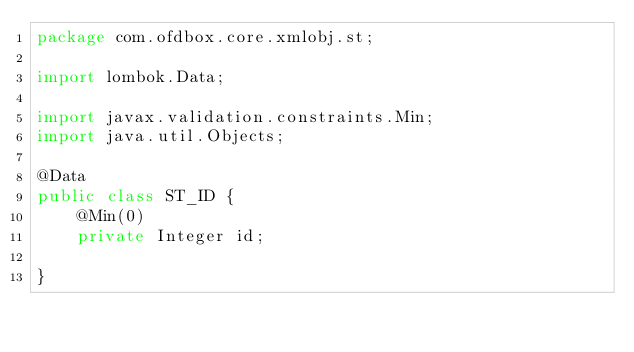Convert code to text. <code><loc_0><loc_0><loc_500><loc_500><_Java_>package com.ofdbox.core.xmlobj.st;

import lombok.Data;

import javax.validation.constraints.Min;
import java.util.Objects;

@Data
public class ST_ID {
    @Min(0)
    private Integer id;

}
</code> 